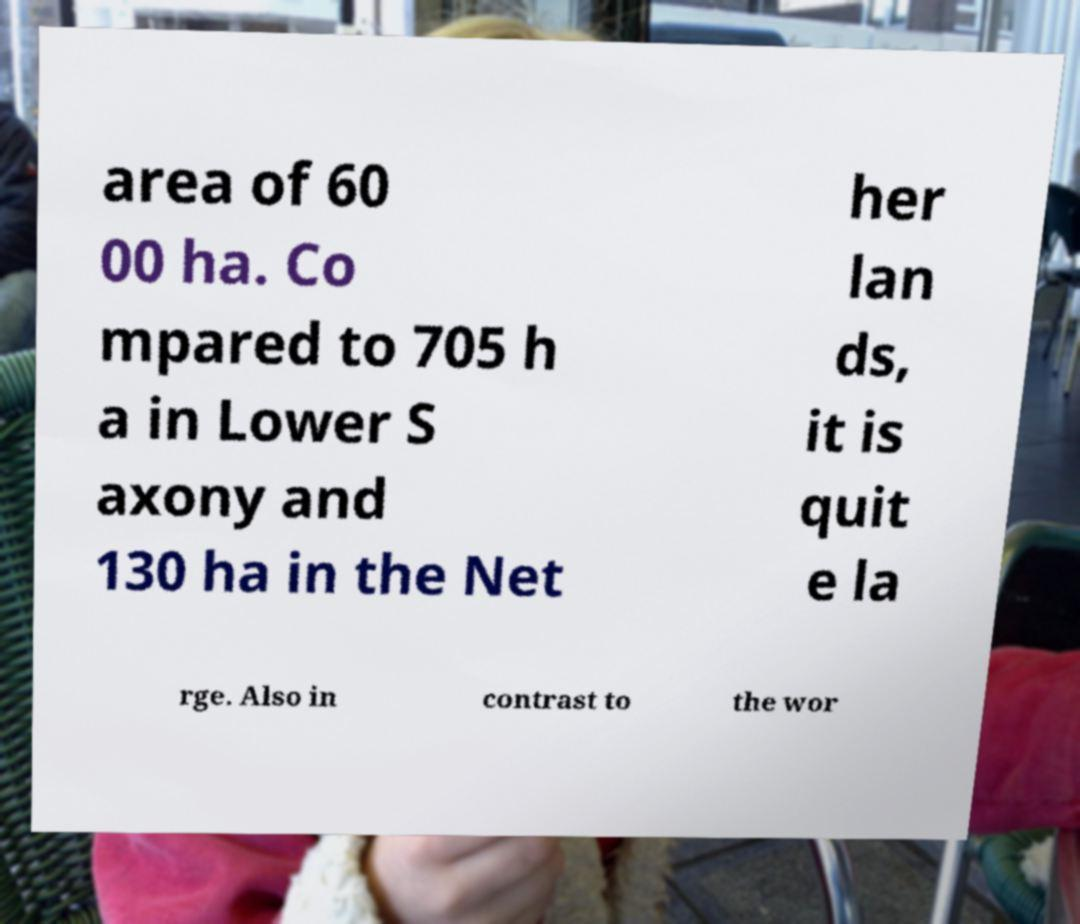Could you extract and type out the text from this image? area of 60 00 ha. Co mpared to 705 h a in Lower S axony and 130 ha in the Net her lan ds, it is quit e la rge. Also in contrast to the wor 